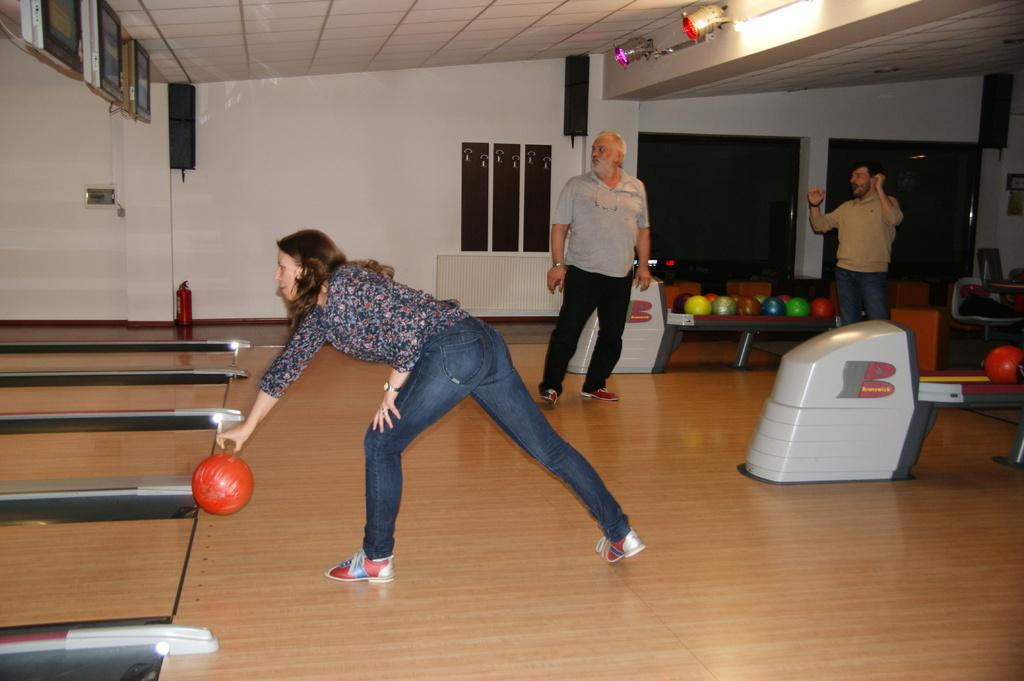How many people are present in the image? There are two people in the image, a woman and a man. What object can be seen in the image besides the people? There is a ball in the image. What type of structure is visible in the image? There is a wall and a roof in the image, suggesting a building or room. What can be used to provide illumination in the image? There is a light in the image. What type of note is the woman holding in the image? There is no note present in the image; the woman is not holding anything. 